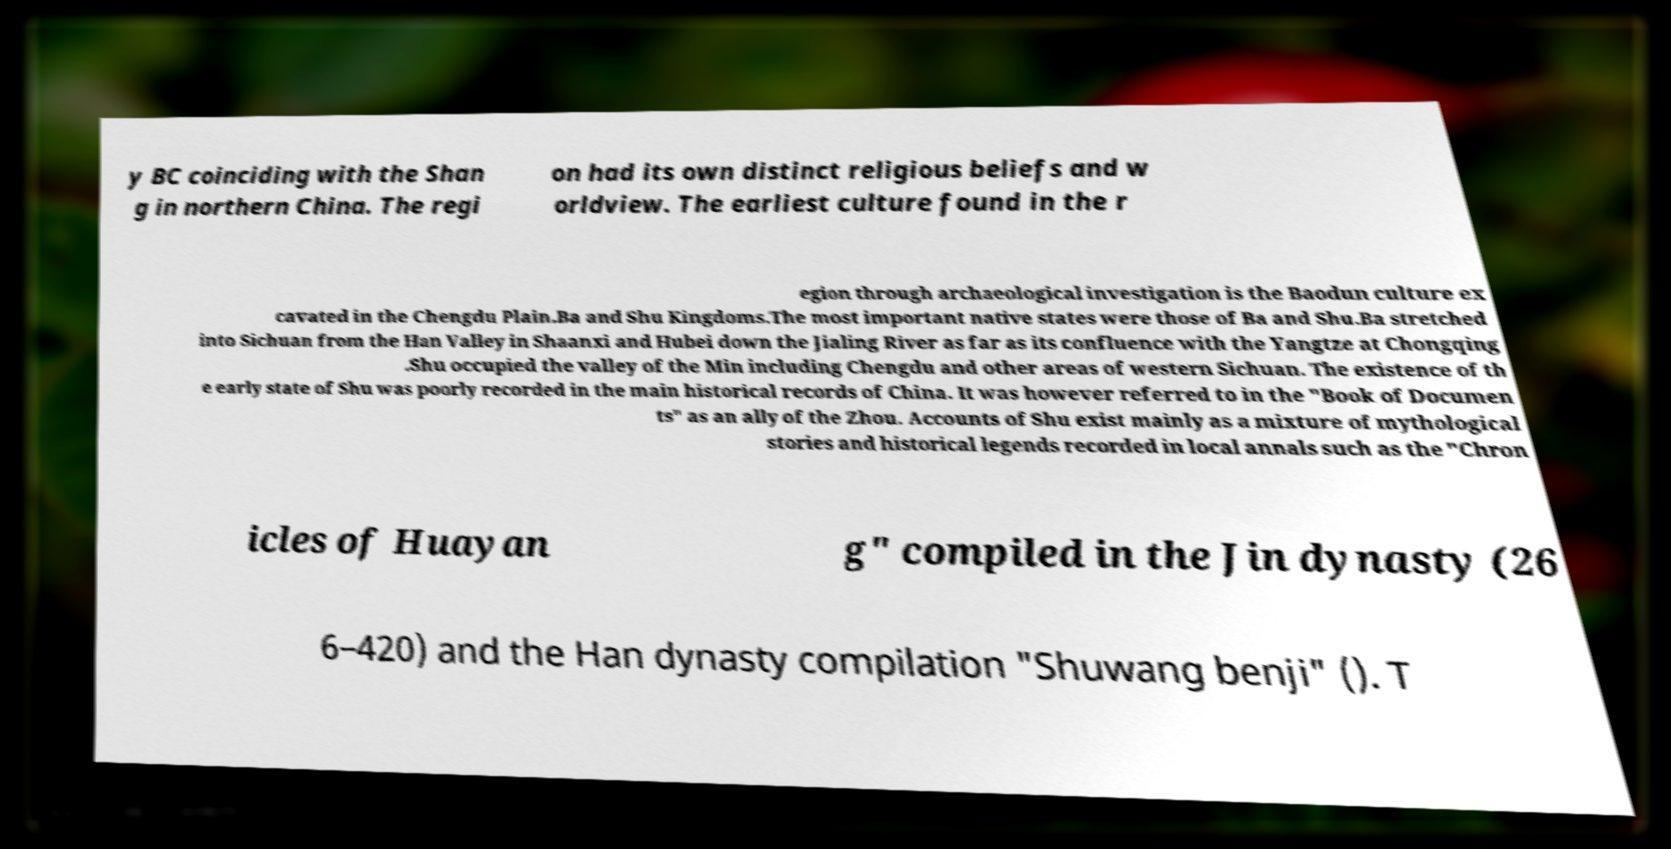Please read and relay the text visible in this image. What does it say? y BC coinciding with the Shan g in northern China. The regi on had its own distinct religious beliefs and w orldview. The earliest culture found in the r egion through archaeological investigation is the Baodun culture ex cavated in the Chengdu Plain.Ba and Shu Kingdoms.The most important native states were those of Ba and Shu.Ba stretched into Sichuan from the Han Valley in Shaanxi and Hubei down the Jialing River as far as its confluence with the Yangtze at Chongqing .Shu occupied the valley of the Min including Chengdu and other areas of western Sichuan. The existence of th e early state of Shu was poorly recorded in the main historical records of China. It was however referred to in the "Book of Documen ts" as an ally of the Zhou. Accounts of Shu exist mainly as a mixture of mythological stories and historical legends recorded in local annals such as the "Chron icles of Huayan g" compiled in the Jin dynasty (26 6–420) and the Han dynasty compilation "Shuwang benji" (). T 